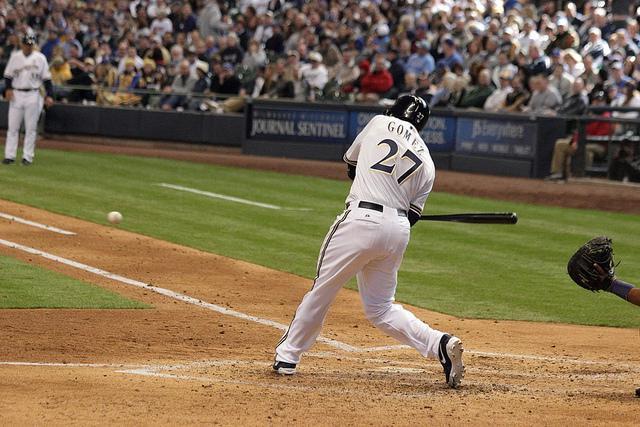How many people are there?
Give a very brief answer. 3. How many orange signs are there?
Give a very brief answer. 0. 